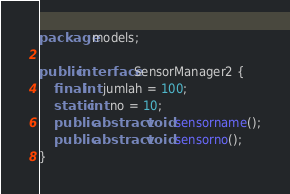<code> <loc_0><loc_0><loc_500><loc_500><_Java_>package models;

public interface SensorManager2 {
	final int jumlah = 100;
	static int no = 10;
	public abstract void sensorname();
	public abstract void sensorno();
}
</code> 